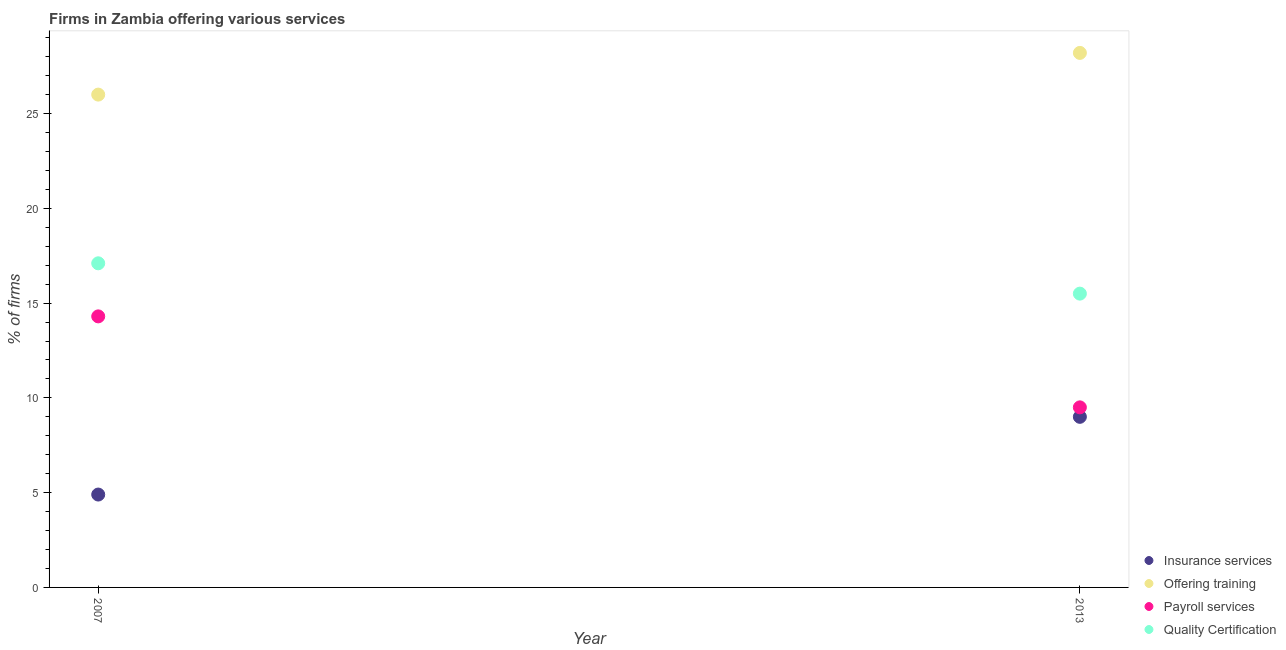Across all years, what is the maximum percentage of firms offering training?
Offer a terse response. 28.2. In which year was the percentage of firms offering payroll services maximum?
Offer a terse response. 2007. In which year was the percentage of firms offering quality certification minimum?
Make the answer very short. 2013. What is the total percentage of firms offering payroll services in the graph?
Provide a short and direct response. 23.8. What is the difference between the percentage of firms offering training in 2007 and that in 2013?
Make the answer very short. -2.2. What is the difference between the percentage of firms offering training in 2007 and the percentage of firms offering quality certification in 2013?
Provide a succinct answer. 10.5. In the year 2013, what is the difference between the percentage of firms offering quality certification and percentage of firms offering training?
Make the answer very short. -12.7. What is the ratio of the percentage of firms offering insurance services in 2007 to that in 2013?
Offer a very short reply. 0.54. Is the percentage of firms offering quality certification in 2007 less than that in 2013?
Offer a very short reply. No. In how many years, is the percentage of firms offering insurance services greater than the average percentage of firms offering insurance services taken over all years?
Offer a very short reply. 1. Is it the case that in every year, the sum of the percentage of firms offering insurance services and percentage of firms offering training is greater than the percentage of firms offering payroll services?
Provide a short and direct response. Yes. Does the percentage of firms offering quality certification monotonically increase over the years?
Give a very brief answer. No. Is the percentage of firms offering insurance services strictly less than the percentage of firms offering quality certification over the years?
Ensure brevity in your answer.  Yes. What is the difference between two consecutive major ticks on the Y-axis?
Your answer should be compact. 5. Does the graph contain any zero values?
Offer a terse response. No. Does the graph contain grids?
Keep it short and to the point. No. Where does the legend appear in the graph?
Give a very brief answer. Bottom right. How many legend labels are there?
Make the answer very short. 4. What is the title of the graph?
Your answer should be compact. Firms in Zambia offering various services . Does "Secondary general" appear as one of the legend labels in the graph?
Make the answer very short. No. What is the label or title of the Y-axis?
Ensure brevity in your answer.  % of firms. What is the % of firms in Offering training in 2007?
Your response must be concise. 26. What is the % of firms of Payroll services in 2007?
Give a very brief answer. 14.3. What is the % of firms of Quality Certification in 2007?
Make the answer very short. 17.1. What is the % of firms in Insurance services in 2013?
Provide a short and direct response. 9. What is the % of firms in Offering training in 2013?
Give a very brief answer. 28.2. What is the % of firms in Payroll services in 2013?
Offer a terse response. 9.5. What is the % of firms of Quality Certification in 2013?
Give a very brief answer. 15.5. Across all years, what is the maximum % of firms in Offering training?
Offer a very short reply. 28.2. Across all years, what is the maximum % of firms in Payroll services?
Give a very brief answer. 14.3. Across all years, what is the maximum % of firms of Quality Certification?
Your response must be concise. 17.1. Across all years, what is the minimum % of firms of Insurance services?
Offer a very short reply. 4.9. What is the total % of firms of Insurance services in the graph?
Offer a terse response. 13.9. What is the total % of firms in Offering training in the graph?
Keep it short and to the point. 54.2. What is the total % of firms of Payroll services in the graph?
Provide a succinct answer. 23.8. What is the total % of firms in Quality Certification in the graph?
Your answer should be very brief. 32.6. What is the difference between the % of firms in Insurance services in 2007 and that in 2013?
Your answer should be compact. -4.1. What is the difference between the % of firms of Offering training in 2007 and that in 2013?
Your answer should be very brief. -2.2. What is the difference between the % of firms in Insurance services in 2007 and the % of firms in Offering training in 2013?
Keep it short and to the point. -23.3. What is the difference between the % of firms in Insurance services in 2007 and the % of firms in Quality Certification in 2013?
Offer a terse response. -10.6. What is the difference between the % of firms in Offering training in 2007 and the % of firms in Quality Certification in 2013?
Give a very brief answer. 10.5. What is the average % of firms of Insurance services per year?
Keep it short and to the point. 6.95. What is the average % of firms of Offering training per year?
Offer a terse response. 27.1. What is the average % of firms in Payroll services per year?
Your response must be concise. 11.9. In the year 2007, what is the difference between the % of firms of Insurance services and % of firms of Offering training?
Keep it short and to the point. -21.1. In the year 2007, what is the difference between the % of firms in Insurance services and % of firms in Payroll services?
Your response must be concise. -9.4. In the year 2007, what is the difference between the % of firms in Insurance services and % of firms in Quality Certification?
Your answer should be very brief. -12.2. In the year 2007, what is the difference between the % of firms of Offering training and % of firms of Quality Certification?
Keep it short and to the point. 8.9. In the year 2007, what is the difference between the % of firms in Payroll services and % of firms in Quality Certification?
Make the answer very short. -2.8. In the year 2013, what is the difference between the % of firms of Insurance services and % of firms of Offering training?
Provide a succinct answer. -19.2. In the year 2013, what is the difference between the % of firms in Insurance services and % of firms in Payroll services?
Your response must be concise. -0.5. In the year 2013, what is the difference between the % of firms in Payroll services and % of firms in Quality Certification?
Make the answer very short. -6. What is the ratio of the % of firms in Insurance services in 2007 to that in 2013?
Provide a short and direct response. 0.54. What is the ratio of the % of firms in Offering training in 2007 to that in 2013?
Offer a terse response. 0.92. What is the ratio of the % of firms of Payroll services in 2007 to that in 2013?
Your response must be concise. 1.51. What is the ratio of the % of firms of Quality Certification in 2007 to that in 2013?
Offer a very short reply. 1.1. What is the difference between the highest and the second highest % of firms in Insurance services?
Your answer should be very brief. 4.1. What is the difference between the highest and the second highest % of firms in Offering training?
Ensure brevity in your answer.  2.2. What is the difference between the highest and the second highest % of firms in Payroll services?
Make the answer very short. 4.8. What is the difference between the highest and the second highest % of firms in Quality Certification?
Your answer should be very brief. 1.6. What is the difference between the highest and the lowest % of firms of Insurance services?
Give a very brief answer. 4.1. What is the difference between the highest and the lowest % of firms in Offering training?
Your response must be concise. 2.2. What is the difference between the highest and the lowest % of firms in Payroll services?
Make the answer very short. 4.8. 